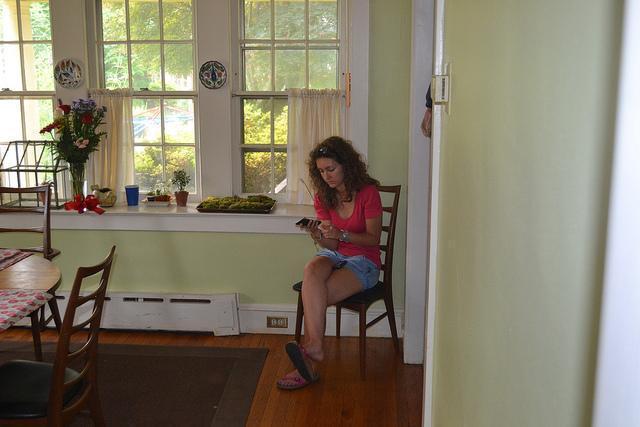How many cats are sitting on the windowsill?
Give a very brief answer. 0. How many people are in the kitchen?
Give a very brief answer. 1. How many windows are open?
Give a very brief answer. 0. How many people are in the room?
Give a very brief answer. 1. How many chairs are in the photo?
Give a very brief answer. 3. 